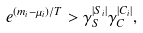<formula> <loc_0><loc_0><loc_500><loc_500>e ^ { \left ( m _ { i } - \mu _ { i } \right ) / T } > \gamma _ { S } ^ { \left | S _ { i } \right | } \gamma _ { C } ^ { \left | C _ { i } \right | } ,</formula> 